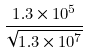Convert formula to latex. <formula><loc_0><loc_0><loc_500><loc_500>\frac { 1 . 3 \times 1 0 ^ { 5 } } { \sqrt { 1 . 3 \times 1 0 ^ { 7 } } }</formula> 